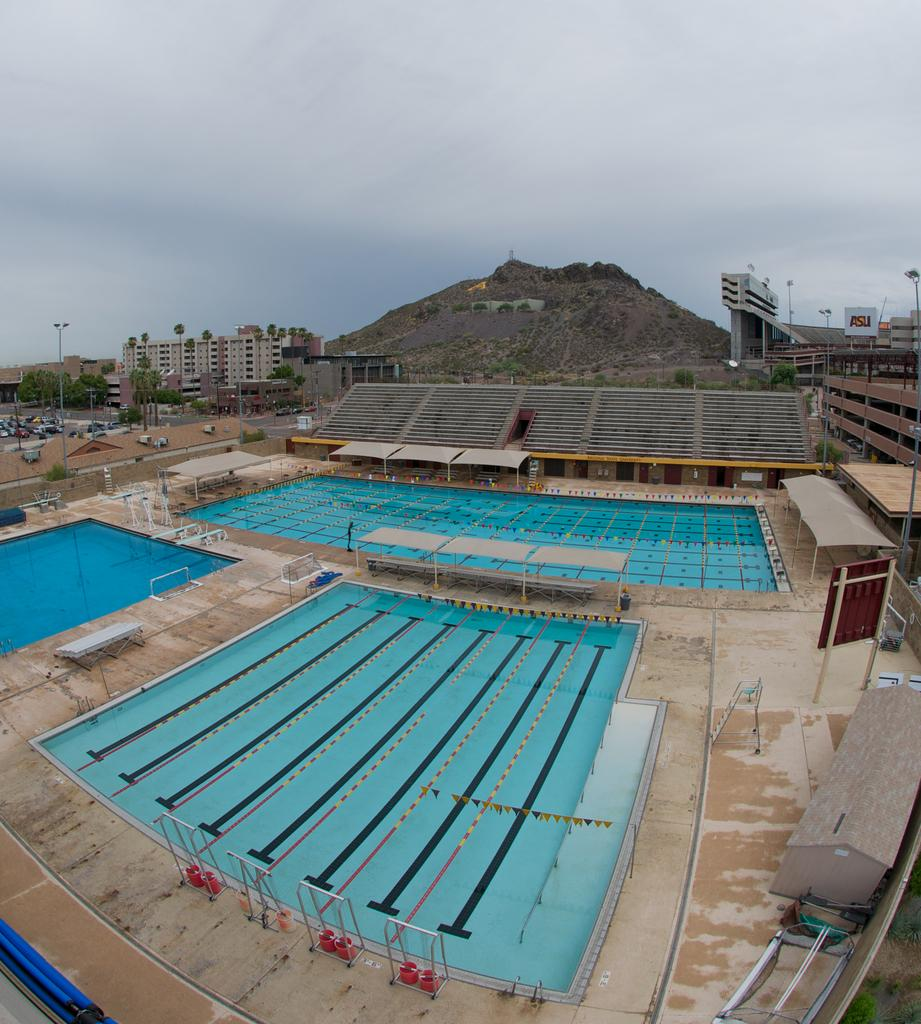How many swimming pools are visible in the image? There are three swimming pools in the image. What can be seen in the background of the image? There are buildings, vehicles, and a mountain in the background of the image. What type of board is being used by the police on the coast in the image? There is no police or coast present in the image, and therefore no board being used. 